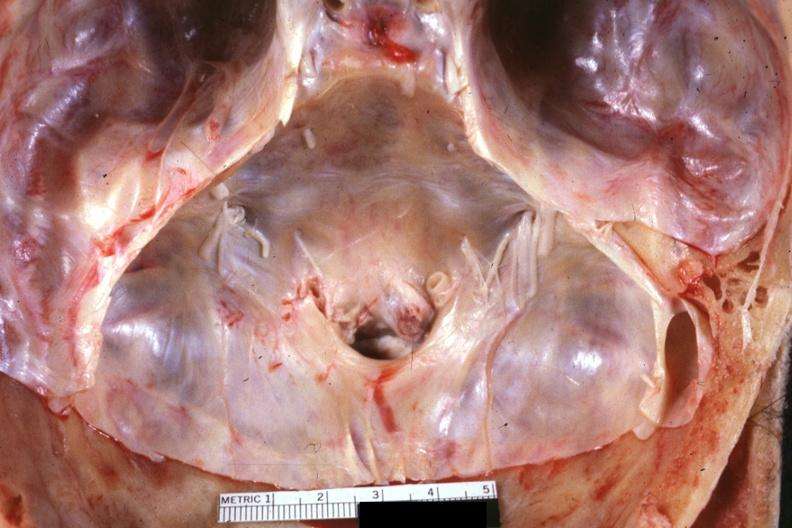what does this image show?
Answer the question using a single word or phrase. Stenotic foramen magnum in situs excellent example 